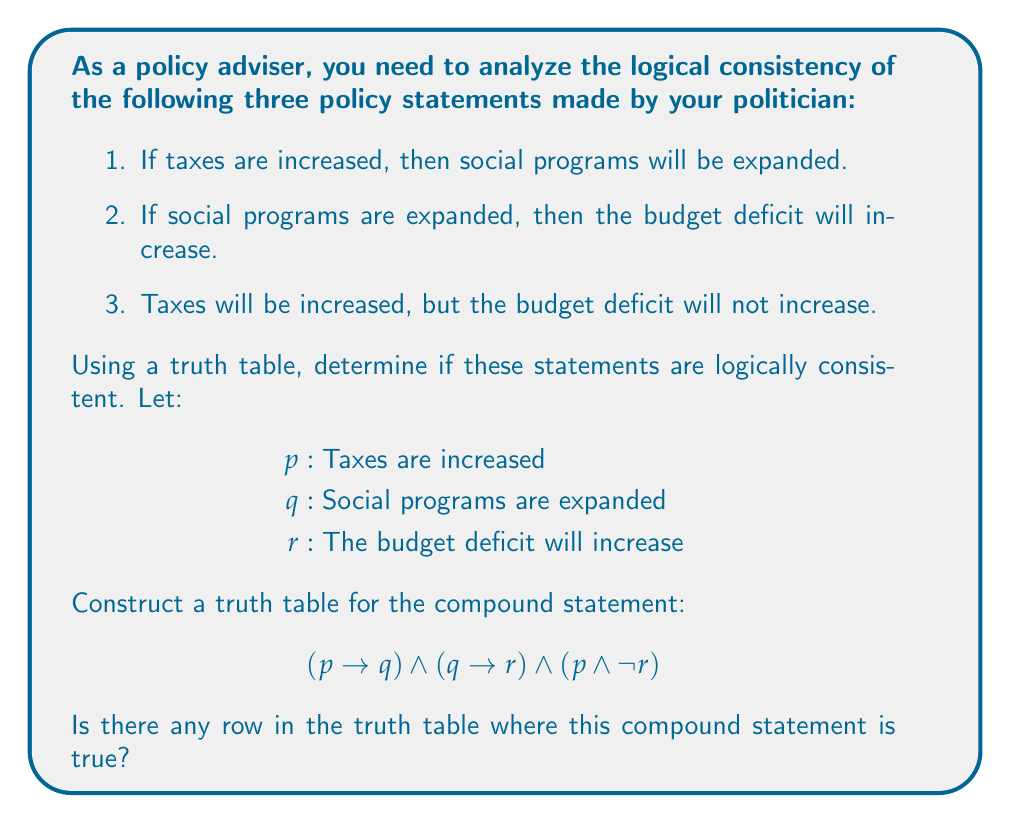Solve this math problem. Let's approach this step-by-step:

1) First, we need to construct a truth table with columns for $p$, $q$, and $r$, and then columns for each part of the compound statement.

2) The truth table will have $2^3 = 8$ rows, as we have 3 variables.

3) Let's evaluate each part of the compound statement:
   a) $(p \rightarrow q)$
   b) $(q \rightarrow r)$
   c) $(p \land \lnot r)$

4) Here's the truth table:

   | $p$ | $q$ | $r$ | $p \rightarrow q$ | $q \rightarrow r$ | $p \land \lnot r$ | $(p \rightarrow q) \land (q \rightarrow r) \land (p \land \lnot r)$ |
   |-----|-----|-----|-------------------|-------------------|-------------------|-----------------------------------------------------------------------|
   | T   | T   | T   | T                 | T                 | F                 | F                                                                     |
   | T   | T   | F   | T                 | F                 | T                 | F                                                                     |
   | T   | F   | T   | F                 | T                 | F                 | F                                                                     |
   | T   | F   | F   | F                 | T                 | T                 | F                                                                     |
   | F   | T   | T   | T                 | T                 | F                 | F                                                                     |
   | F   | T   | F   | T                 | F                 | F                 | F                                                                     |
   | F   | F   | T   | T                 | T                 | F                 | F                                                                     |
   | F   | F   | F   | T                 | T                 | F                 | F                                                                     |

5) The last column represents the entire compound statement. If there's any row where this column is true, the statements are logically consistent.

6) As we can see, there is no row where the entire compound statement is true.

Therefore, the three policy statements are not logically consistent. It's impossible for all three statements to be true simultaneously.
Answer: The statements are logically inconsistent. 